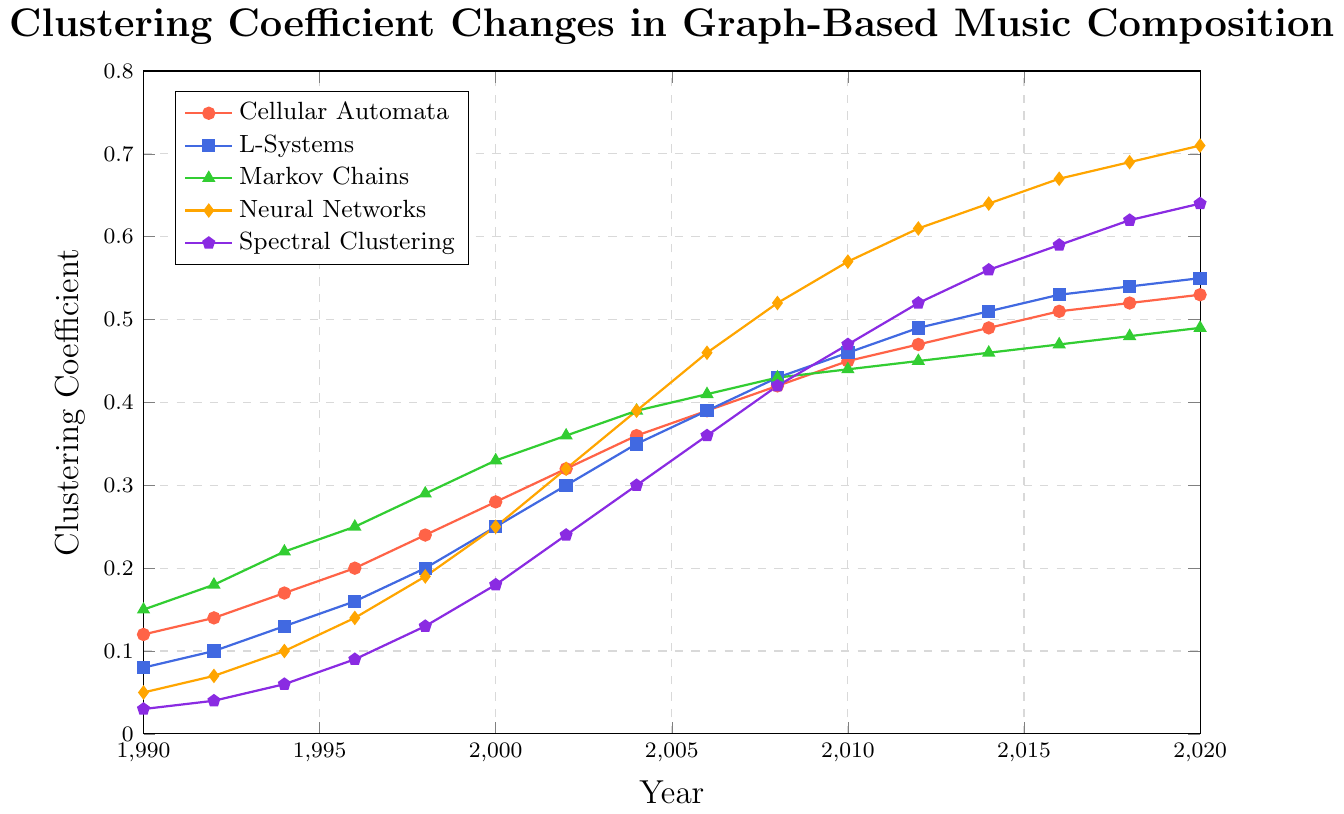Which technique had the highest clustering coefficient in the year 2000? By examining the value points on the y-axis for each technique in the year 2000, the Neural Networks curve has the highest value.
Answer: Neural Networks In which year did the clustering coefficient of Neural Networks surpass 0.6? Check the trend line for Neural Networks and observe the clustering coefficients year by year. It surpasses 0.6 in 2012.
Answer: 2012 By how much did the clustering coefficient of Markov Chains change from 1994 to 1998? The clustering coefficient of Markov Chains was 0.22 in 1994 and 0.29 in 1998. Subtract 0.22 from 0.29 to find the difference. 0.29 - 0.22 = 0.07
Answer: 0.07 Compare the clustering coefficient of Cellular Automata and Spectral Clustering in 2016. Which is higher and by how much? Cellular Automata in 2016 is at 0.51, and Spectral Clustering is at 0.59. Compare these values, and the difference is 0.59 - 0.51 = 0.08
Answer: Spectral Clustering by 0.08 Identify the technique with the steepest increase in clustering coefficient between 2008 and 2016. Calculate the slope of the increase for each technique between 2008 and 2016. Neural Networks move from 0.52 to 0.67, a rise of 0.67 - 0.52 = 0.15. It has the steepest increase.
Answer: Neural Networks What is the overall trend in clustering coefficients for all techniques from 1990 to 2020? Observing the graph, all lines are generally trending upward, indicating an overall increase in clustering coefficients for all techniques over the years.
Answer: Upward trend In what year did L-Systems and Markov Chains have the same clustering coefficient? Looking at the plot, L-Systems and Markov Chains had the same clustering coefficient around the year 2006, both at approximately 0.39.
Answer: 2006 What is the average clustering coefficient of Spectral Clustering from 2000 to 2010? Sum the values for Spectral Clustering: 0.18 (2000) + 0.24 (2002) + 0.30 (2004) + 0.36 (2006) + 0.42 (2008) + 0.47 (2010) = 1.97. Then divide by the number of years (6): 1.97/6 = 0.32833.
Answer: 0.32833 Between 2012 and 2018, which technique grew the fastest in terms of clustering coefficient? Calculate the differences for each technique: Cellular Automata (0.52 - 0.47 = 0.05), L-Systems (0.54 - 0.49 = 0.05), Markov Chains (0.48 - 0.45 = 0.03), Neural Networks (0.69 - 0.61 = 0.08), Spectral Clustering (0.62 - 0.52 = 0.10). Spectral Clustering grew the most.
Answer: Spectral Clustering 